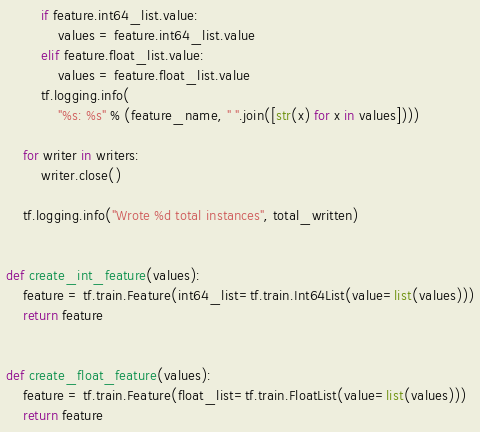<code> <loc_0><loc_0><loc_500><loc_500><_Python_>        if feature.int64_list.value:
            values = feature.int64_list.value
        elif feature.float_list.value:
            values = feature.float_list.value
        tf.logging.info(
            "%s: %s" % (feature_name, " ".join([str(x) for x in values])))

    for writer in writers:
        writer.close()

    tf.logging.info("Wrote %d total instances", total_written)


def create_int_feature(values):
    feature = tf.train.Feature(int64_list=tf.train.Int64List(value=list(values)))
    return feature


def create_float_feature(values):
    feature = tf.train.Feature(float_list=tf.train.FloatList(value=list(values)))
    return feature
</code> 